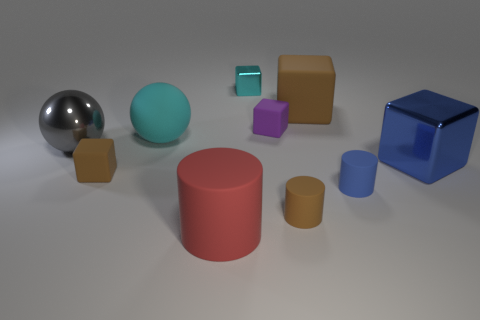What number of rubber objects are left of the large brown rubber thing and behind the tiny brown cylinder?
Your response must be concise. 3. There is a big gray metal thing; are there any large things in front of it?
Ensure brevity in your answer.  Yes. There is a big metal object that is right of the purple matte object; is it the same shape as the tiny brown matte object that is to the right of the small purple rubber thing?
Provide a succinct answer. No. How many things are either big gray balls or tiny rubber things in front of the gray metal sphere?
Your response must be concise. 4. What number of other things are there of the same shape as the small blue rubber thing?
Make the answer very short. 2. Is the material of the big cube that is on the right side of the big brown matte object the same as the tiny brown cylinder?
Your answer should be compact. No. What number of objects are either small brown matte cylinders or small purple rubber cubes?
Offer a terse response. 2. There is a purple rubber thing that is the same shape as the tiny cyan thing; what is its size?
Make the answer very short. Small. How big is the cyan shiny object?
Your answer should be very brief. Small. Is the number of rubber objects that are in front of the tiny brown rubber cube greater than the number of cyan things?
Provide a succinct answer. Yes. 